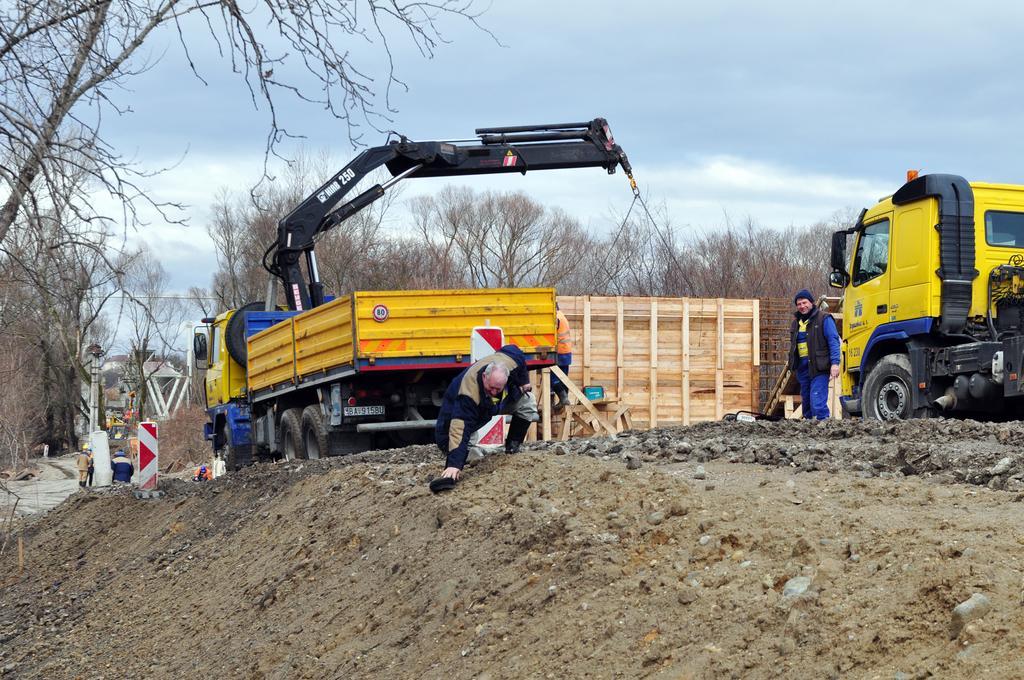Please provide a concise description of this image. In this image there are vehicles and a wooden box, near the vehicle there is a man standing and a man is bending, in the background there are trees and the sky. 